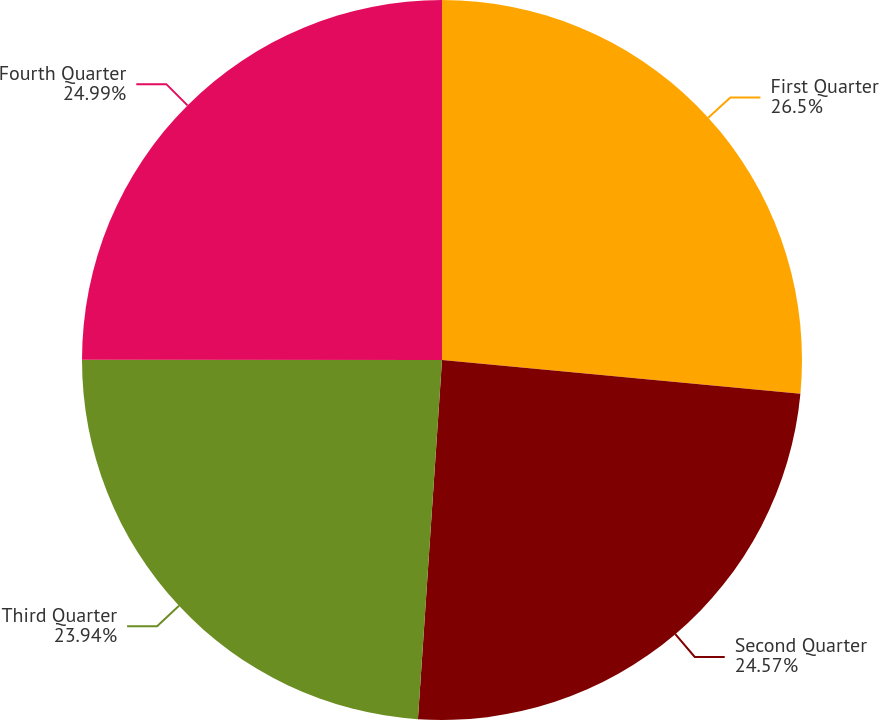Convert chart to OTSL. <chart><loc_0><loc_0><loc_500><loc_500><pie_chart><fcel>First Quarter<fcel>Second Quarter<fcel>Third Quarter<fcel>Fourth Quarter<nl><fcel>26.49%<fcel>24.57%<fcel>23.94%<fcel>24.99%<nl></chart> 